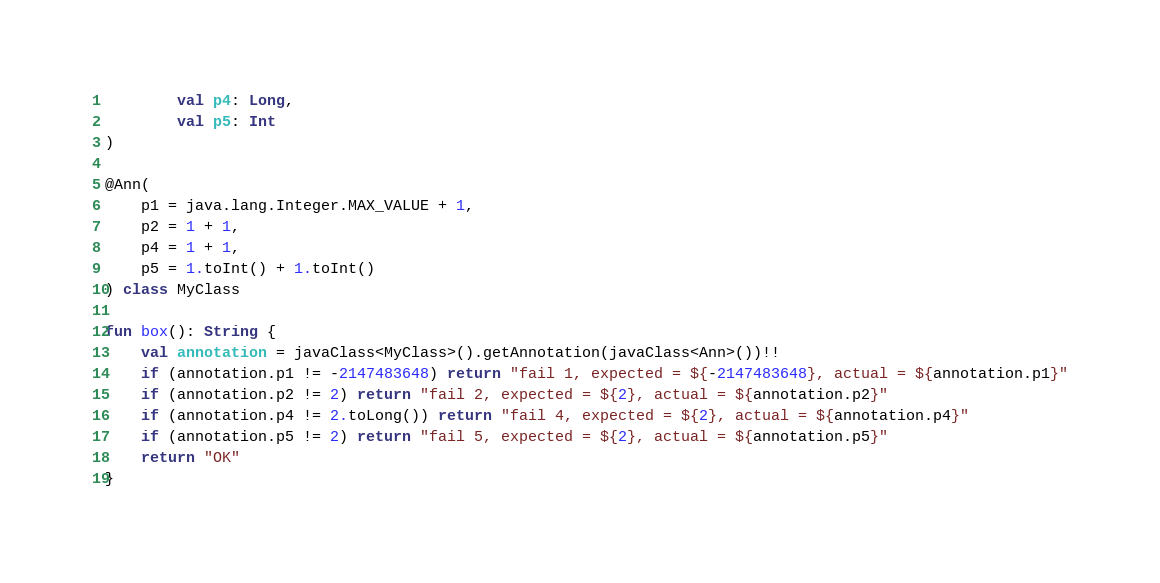Convert code to text. <code><loc_0><loc_0><loc_500><loc_500><_Kotlin_>        val p4: Long,
        val p5: Int
)

@Ann(
    p1 = java.lang.Integer.MAX_VALUE + 1,
    p2 = 1 + 1,
    p4 = 1 + 1,
    p5 = 1.toInt() + 1.toInt()
) class MyClass

fun box(): String {
    val annotation = javaClass<MyClass>().getAnnotation(javaClass<Ann>())!!
    if (annotation.p1 != -2147483648) return "fail 1, expected = ${-2147483648}, actual = ${annotation.p1}"
    if (annotation.p2 != 2) return "fail 2, expected = ${2}, actual = ${annotation.p2}"
    if (annotation.p4 != 2.toLong()) return "fail 4, expected = ${2}, actual = ${annotation.p4}"
    if (annotation.p5 != 2) return "fail 5, expected = ${2}, actual = ${annotation.p5}"
    return "OK"
}</code> 